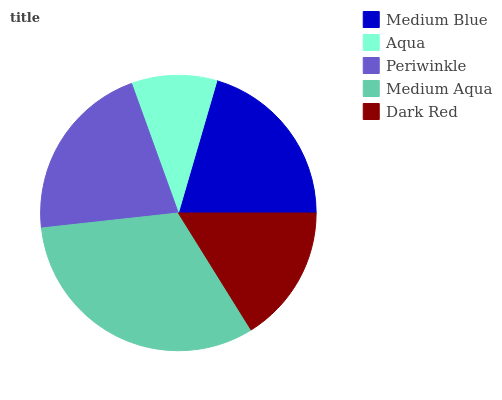Is Aqua the minimum?
Answer yes or no. Yes. Is Medium Aqua the maximum?
Answer yes or no. Yes. Is Periwinkle the minimum?
Answer yes or no. No. Is Periwinkle the maximum?
Answer yes or no. No. Is Periwinkle greater than Aqua?
Answer yes or no. Yes. Is Aqua less than Periwinkle?
Answer yes or no. Yes. Is Aqua greater than Periwinkle?
Answer yes or no. No. Is Periwinkle less than Aqua?
Answer yes or no. No. Is Medium Blue the high median?
Answer yes or no. Yes. Is Medium Blue the low median?
Answer yes or no. Yes. Is Dark Red the high median?
Answer yes or no. No. Is Periwinkle the low median?
Answer yes or no. No. 